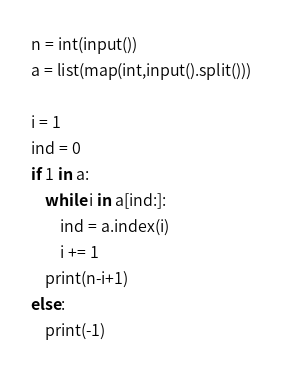Convert code to text. <code><loc_0><loc_0><loc_500><loc_500><_Python_>n = int(input())
a = list(map(int,input().split()))

i = 1
ind = 0
if 1 in a:
    while i in a[ind:]:
    	ind = a.index(i)
    	i += 1
    print(n-i+1)
else:
    print(-1)
</code> 